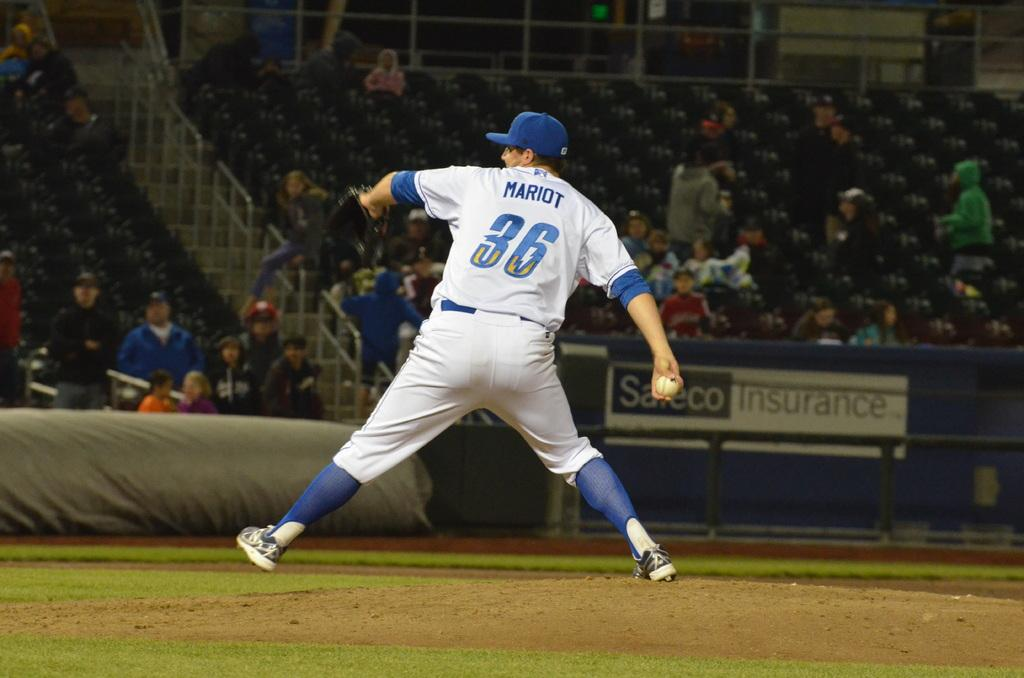<image>
Give a short and clear explanation of the subsequent image. Baseball player number 36 throwing the baseball towards the batter. 